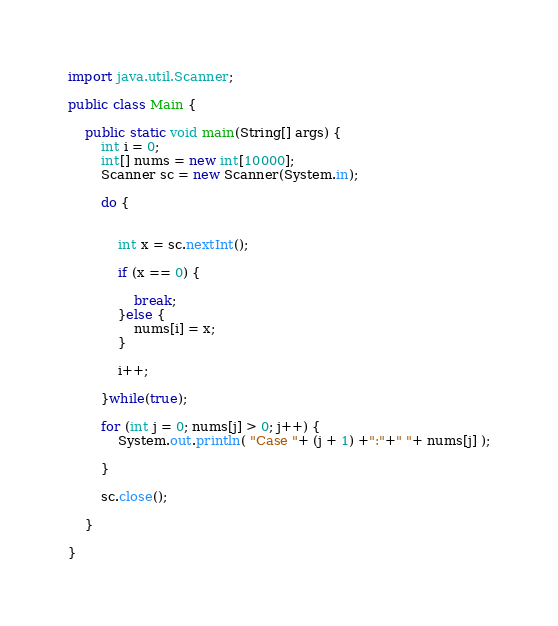Convert code to text. <code><loc_0><loc_0><loc_500><loc_500><_Java_>import java.util.Scanner;

public class Main {

	public static void main(String[] args) {
		int i = 0;
		int[] nums = new int[10000];
		Scanner sc = new Scanner(System.in);

		do {


	        int x = sc.nextInt();

	        if (x == 0) {

	        	break;
	        }else {
	        	nums[i] = x;
	        }

	        i++;

		}while(true);

		for (int j = 0; nums[j] > 0; j++) {
			System.out.println( "Case "+ (j + 1) +":"+" "+ nums[j] );

		}

		sc.close();

	}

}

</code> 